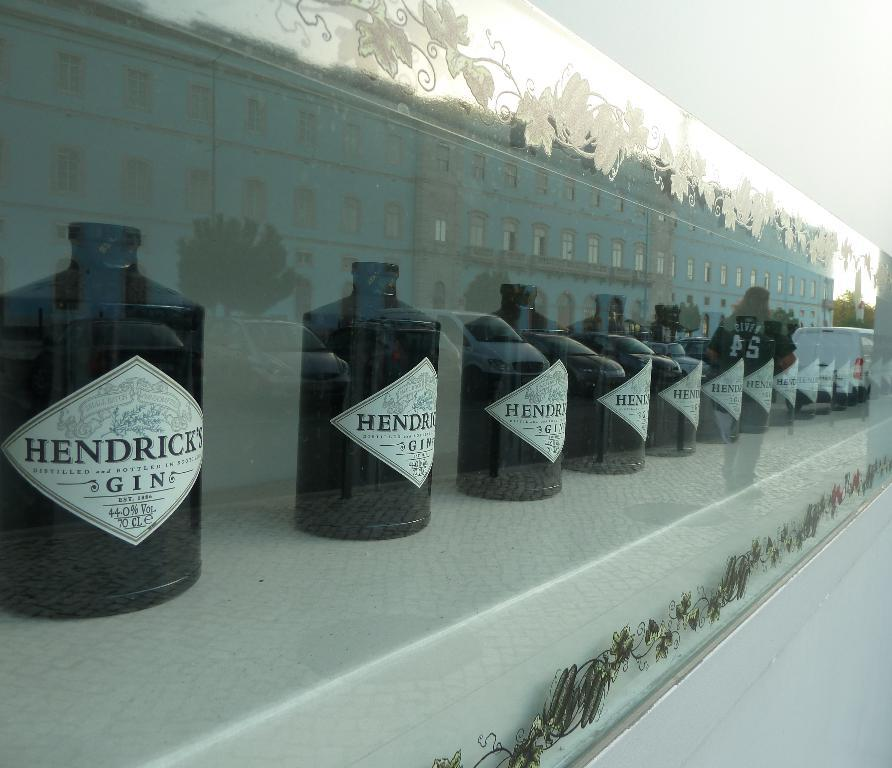<image>
Share a concise interpretation of the image provided. The fluid in the bottles is called Hendricks Gin 